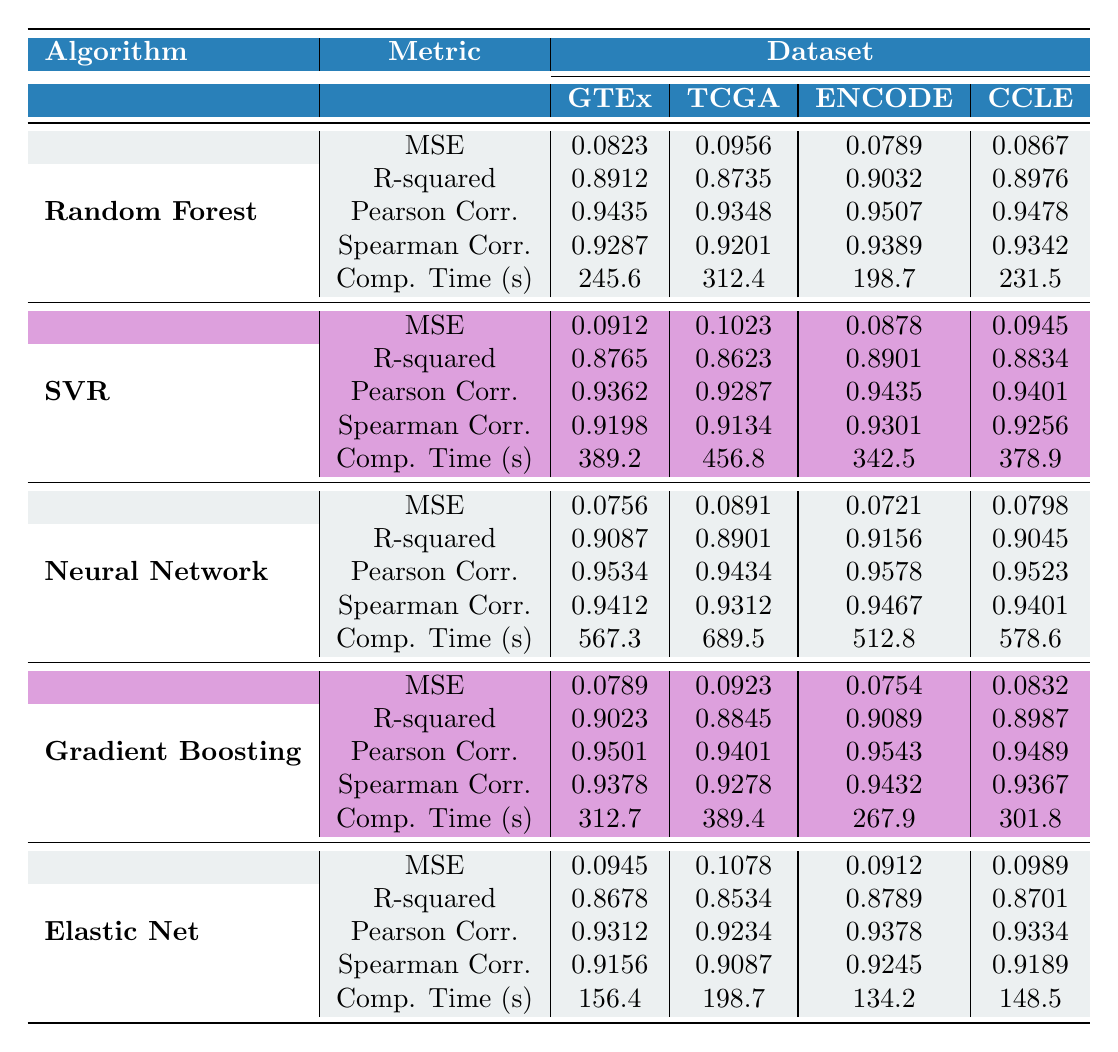What is the Mean Squared Error for the Random Forest algorithm on the GTEx dataset? The Mean Squared Error (MSE) for the Random Forest algorithm on the GTEx dataset is listed directly in the table, under the corresponding row and column. It is 0.0823.
Answer: 0.0823 Which algorithm has the highest R-squared value on the ENCODE dataset? The R-squared values for each algorithm on the ENCODE dataset can be compared directly from the table. The Neural Network algorithm has the highest R-squared value of 0.9156.
Answer: Neural Network What is the average computation time for the Support Vector Regression across all datasets? To find the average computation time for the Support Vector Regression, we first add up the computation times: 389.2 + 456.8 + 342.5 + 423.7 + 378.9 = 1991.1 seconds. Then, we divide by the number of datasets, which is 5. Thus, 1991.1 / 5 = 398.22 seconds.
Answer: 398.22 Does the Gradient Boosting algorithm have a lower Mean Squared Error on the GTEx dataset compared to the Elastic Net algorithm? The Mean Squared Error for Gradient Boosting on the GTEx dataset is 0.0789, while for Elastic Net it is 0.0945. Since 0.0789 is less than 0.0945, the statement is true.
Answer: Yes Which algorithm showed the most consistent performance across different datasets based on the Pearson Correlation metrics? To assess consistency in Pearson Correlation, look at the maximum and minimum values across datasets for each algorithm. Gradually examining these values shows that the Neural Network has Pearson Correlation values ranging from 0.9434 to 0.9578, which are relatively close to each other. This indicates less variability compared to other algorithms.
Answer: Neural Network 